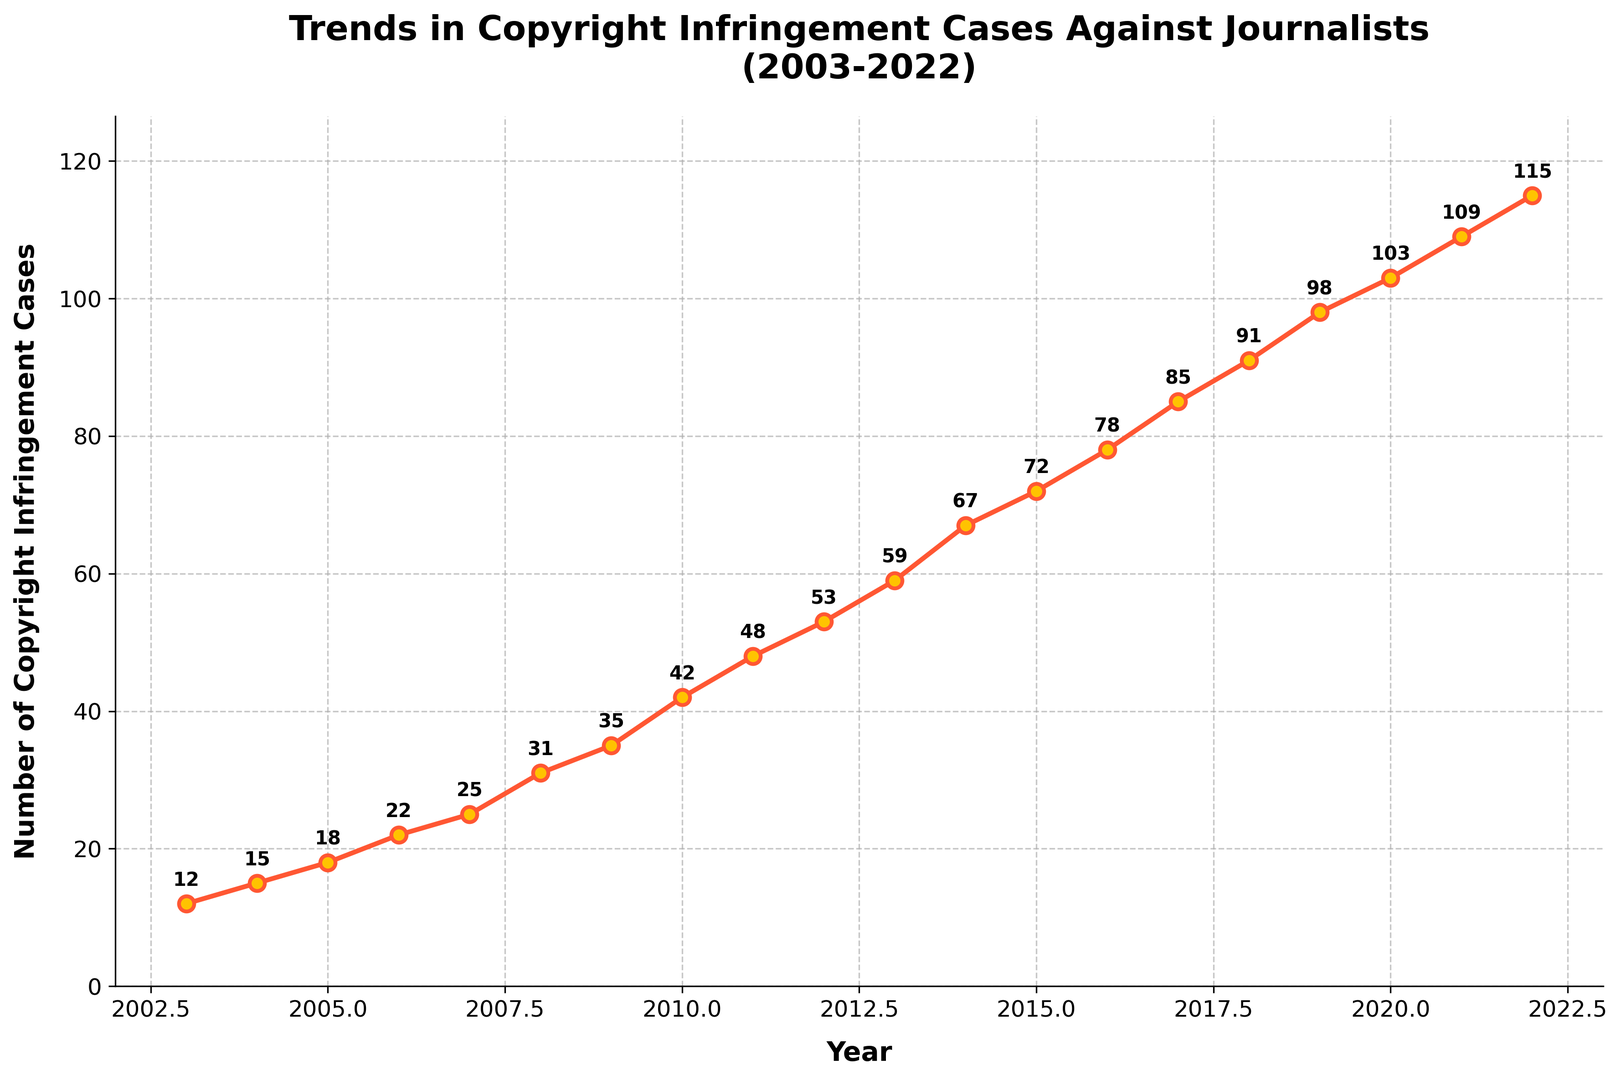What is the total number of copyright infringement cases in 2022? Look for the data point in 2022 on the y-axis. The value is 115.
Answer: 115 How many more cases were there in 2022 compared to 2003? Subtract the number of cases in 2003 from the number of cases in 2022 (115 - 12 = 103).
Answer: 103 What is the average number of copyright infringement cases from 2008 to 2012? Sum the cases from 2008 to 2012 (31 + 35 + 42 + 48 + 53 = 209), then divide by the number of years (209 / 5 = 41.8).
Answer: 41.8 Which year shows the highest number of copyright infringement cases? Look for the peak point on the y-axis. 2022 has the highest number at 115 cases.
Answer: 2022 How many copyright infringement cases were there in the year halfway between 2003 and 2022? Find the middle year (between 2003 and 2022) which is around 2012. The number of cases in 2012 is 53.
Answer: 53 By how much did the number of cases increase from 2010 to 2015? Subtract the number of cases in 2010 from the number of cases in 2015 (72 - 42 = 30).
Answer: 30 How many cases were observed on average per year from 2003 to 2022? Sum all the cases from 2003 to 2022, which equals 1124, then divide by the number of years (1124 / 20 = 56.2).
Answer: 56.2 In which year was the increase in cases from the previous year the highest? Look at the differences year by year and find the largest one. The maximum increase is 10 cases from 2020 to 2021 (109 - 103 = 6).
Answer: 2014 What is the trend in the number of copyright infringement cases over the 20 years? The trend is a consistent increase, as indicated by the upward slope of the line.
Answer: Increasing Which two consecutive years show the largest decrease in the increment of cases? Evaluate the differences between consecutive years and find the largest decrease in the increment. From 2021 to 2022, the increase is 6 (115 - 109 = 6), and from 2020 to 2021, the increase is also 6 (109 - 103 = 6). Hence, the largest decrease is zero, meaning the increments are consistent.
Answer: None 